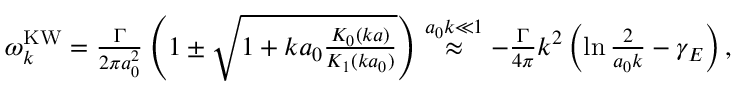<formula> <loc_0><loc_0><loc_500><loc_500>\begin{array} { r } { \omega _ { k } ^ { K W } = \frac { \Gamma } { 2 \pi a _ { 0 } ^ { 2 } } \left ( 1 \pm \sqrt { 1 + k a _ { 0 } \frac { K _ { 0 } ( k a ) } { K _ { 1 } ( k a _ { 0 } ) } } \right ) \stackrel { a _ { 0 } k \ll 1 } { \approx } - \frac { \Gamma } { 4 \pi } k ^ { 2 } \left ( \ln \frac { 2 } { a _ { 0 } k } - \gamma _ { E } \right ) , } \end{array}</formula> 